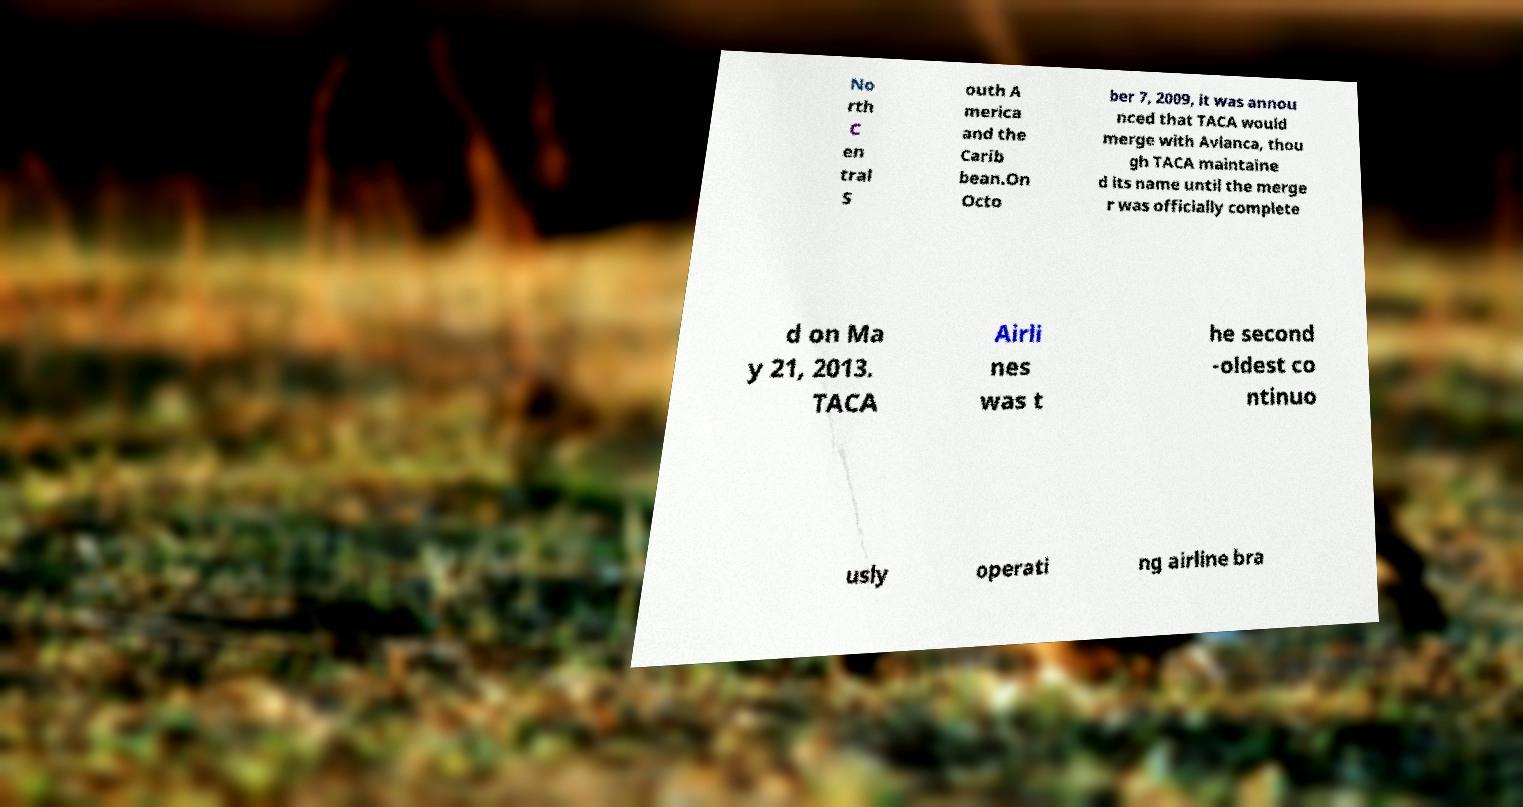There's text embedded in this image that I need extracted. Can you transcribe it verbatim? No rth C en tral S outh A merica and the Carib bean.On Octo ber 7, 2009, it was annou nced that TACA would merge with Avianca, thou gh TACA maintaine d its name until the merge r was officially complete d on Ma y 21, 2013. TACA Airli nes was t he second -oldest co ntinuo usly operati ng airline bra 